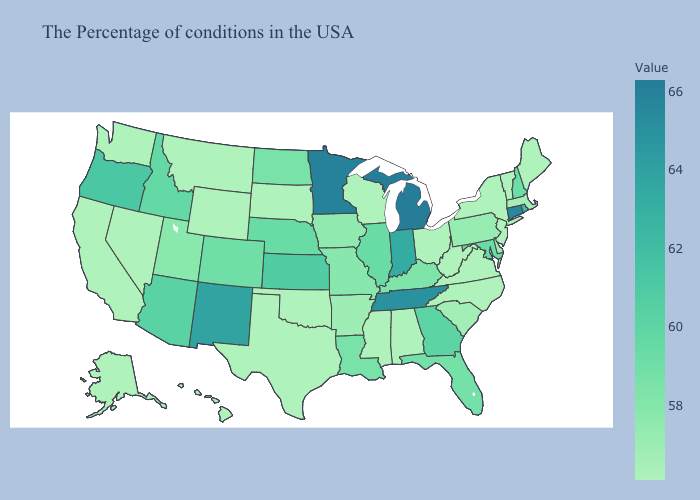Does Washington have the highest value in the USA?
Write a very short answer. No. Does the map have missing data?
Be succinct. No. Does Florida have a higher value than Michigan?
Quick response, please. No. Does West Virginia have the lowest value in the USA?
Quick response, please. Yes. Does the map have missing data?
Answer briefly. No. Among the states that border New Hampshire , does Massachusetts have the lowest value?
Write a very short answer. No. Does Kansas have the highest value in the MidWest?
Write a very short answer. No. 